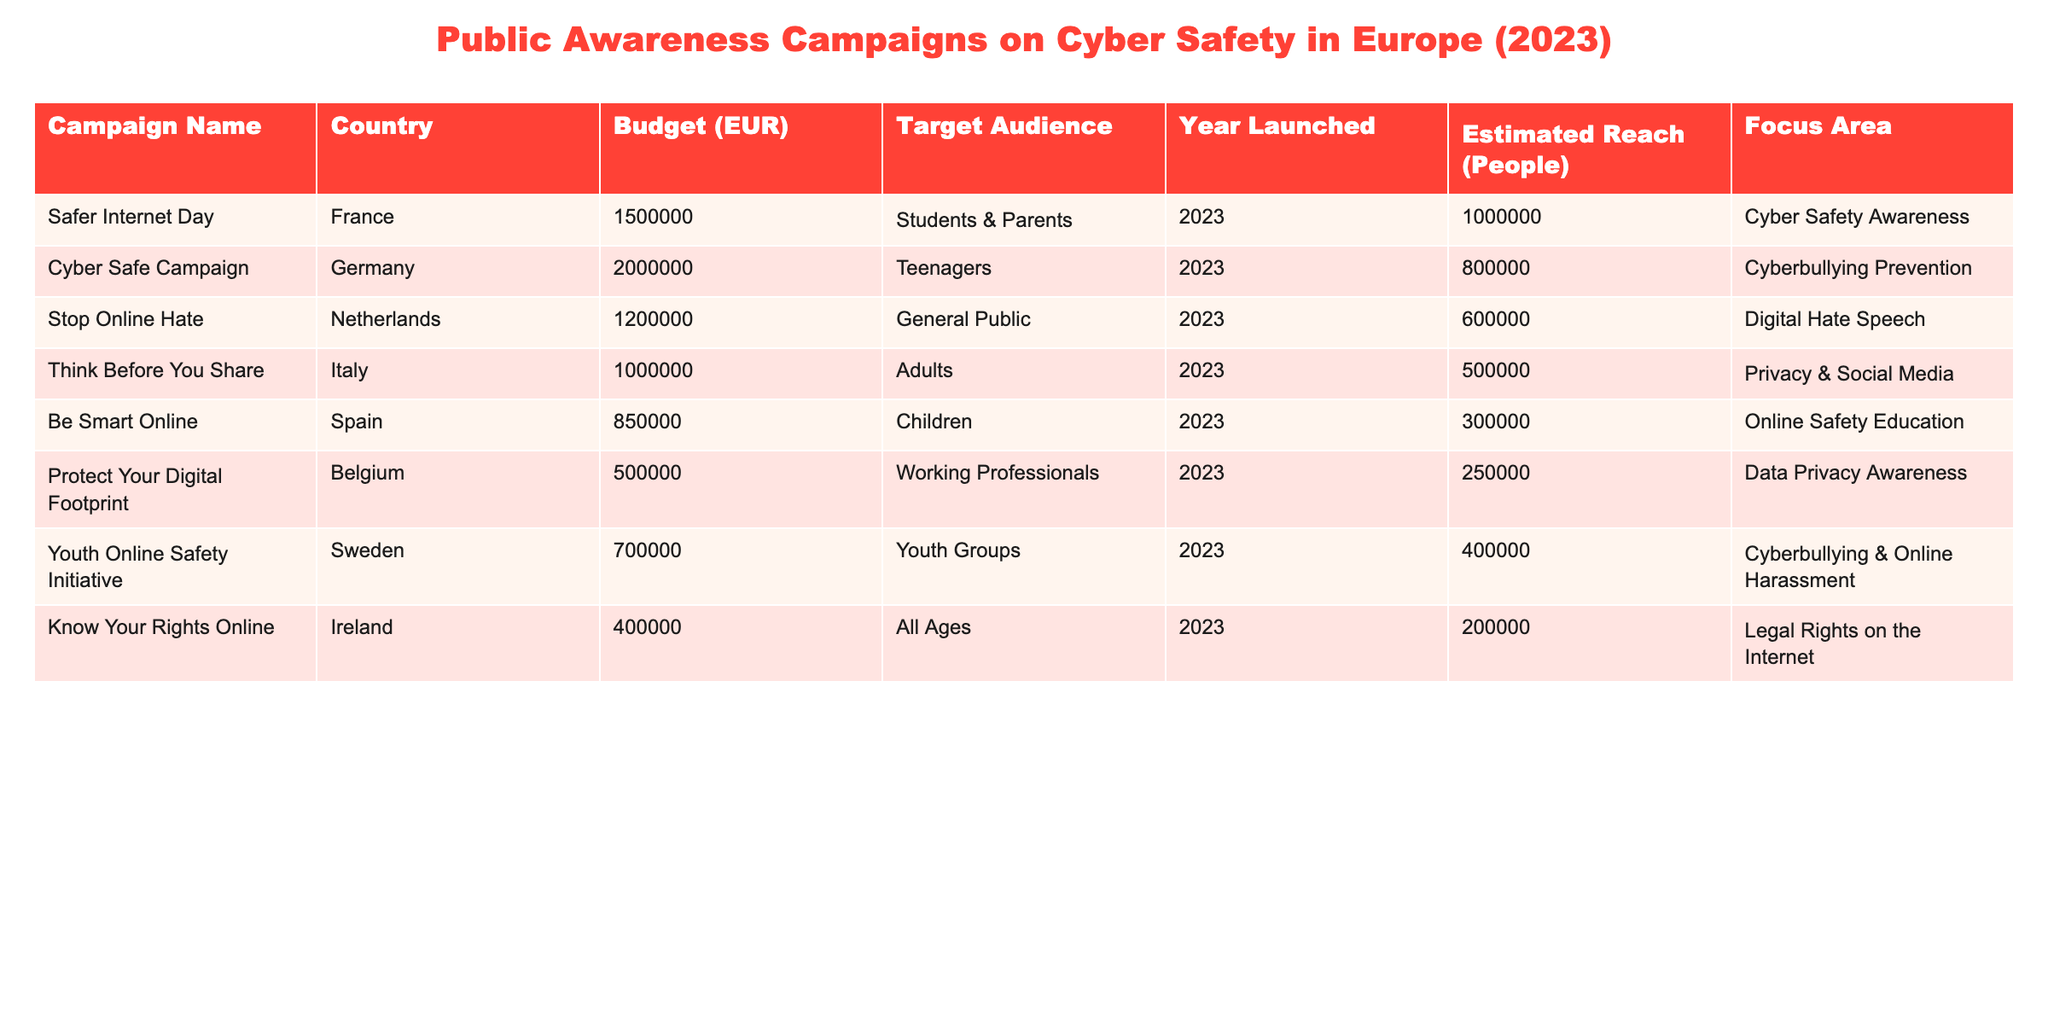What is the total budget for all campaigns listed in the table? To find the total budget, I will sum the budget figures for each campaign: 1,500,000 + 2,000,000 + 1,200,000 + 1,000,000 + 850,000 + 500,000 + 700,000 + 400,000 = 8,150,000.
Answer: 8,150,000 Which campaign has the highest estimated reach? By checking the "Estimated Reach" column for the maximum value, I find that "Safer Internet Day" has the highest reach of 1,000,000 people.
Answer: Safer Internet Day Are there any campaigns targeting working professionals? Looking through the "Target Audience" column, "Protect Your Digital Footprint" targets working professionals, confirming the statement is true.
Answer: Yes What is the average budget of the campaigns? I will calculate the average budget by summing the budgets: 1,500,000 + 2,000,000 + 1,200,000 + 1,000,000 + 850,000 + 500,000 + 700,000 + 400,000 = 8,150,000. Next, I divide by the number of campaigns (8): 8,150,000 / 8 = 1,018,750.
Answer: 1,018,750 How many campaigns focus on cyberbullying prevention or online harassment? I will count "Cyber Safe Campaign" and "Youth Online Safety Initiative," both of which focus on cyberbullying and online harassment, resulting in a total of 2 campaigns.
Answer: 2 Is there any campaign with a focus area on data privacy awareness? Scanning the focus areas, "Protect Your Digital Footprint" explicitly addresses data privacy awareness, so the fact is true.
Answer: Yes What percentage of the total estimated reach is attributed to the "Be Smart Online" campaign? The total reach is 3,700,000 (sum of all reaches). The reach for "Be Smart Online" is 300,000. The percentage is calculated as (300,000 / 3,700,000) * 100 ≈ 8.11%.
Answer: 8.11% Which country has the smallest budget for their campaign? Comparing all campaign budgets, "Protect Your Digital Footprint" from Belgium has the smallest budget of 500,000.
Answer: Belgium Are there campaigns aimed at both teenagers and children? Checking the "Target Audience," I find "Cyber Safe Campaign" targets teenagers and "Be Smart Online" targets children, confirming multiple campaigns target these groups.
Answer: Yes What is the total estimated reach for campaigns launched in France and Germany combined? The reach for "Safer Internet Day" in France is 1,000,000 and for "Cyber Safe Campaign" in Germany is 800,000. Summing these gives 1,000,000 + 800,000 = 1,800,000.
Answer: 1,800,000 